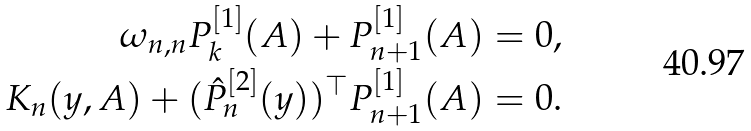<formula> <loc_0><loc_0><loc_500><loc_500>\omega _ { n , n } P ^ { [ 1 ] } _ { k } ( A ) + P ^ { [ 1 ] } _ { n + 1 } ( A ) & = 0 , \\ K _ { n } ( y , A ) + ( \hat { P } _ { n } ^ { [ 2 ] } ( y ) ) ^ { \top } P ^ { [ 1 ] } _ { n + 1 } ( A ) & = 0 .</formula> 